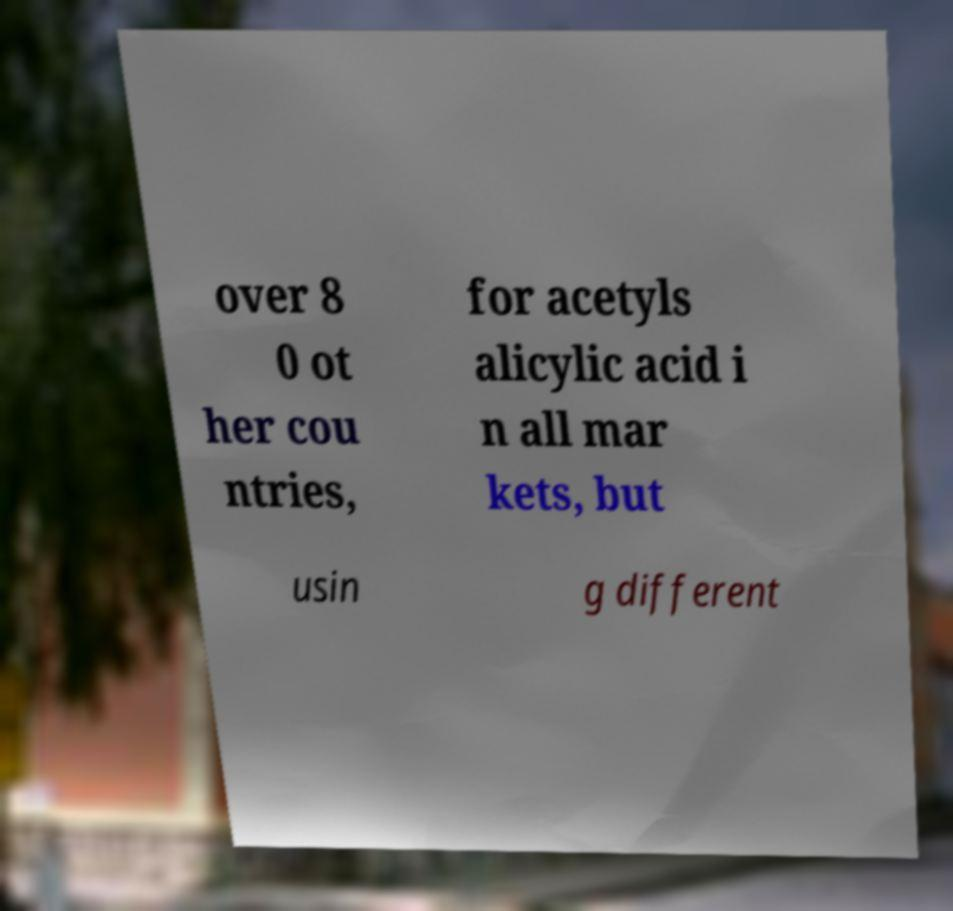There's text embedded in this image that I need extracted. Can you transcribe it verbatim? over 8 0 ot her cou ntries, for acetyls alicylic acid i n all mar kets, but usin g different 